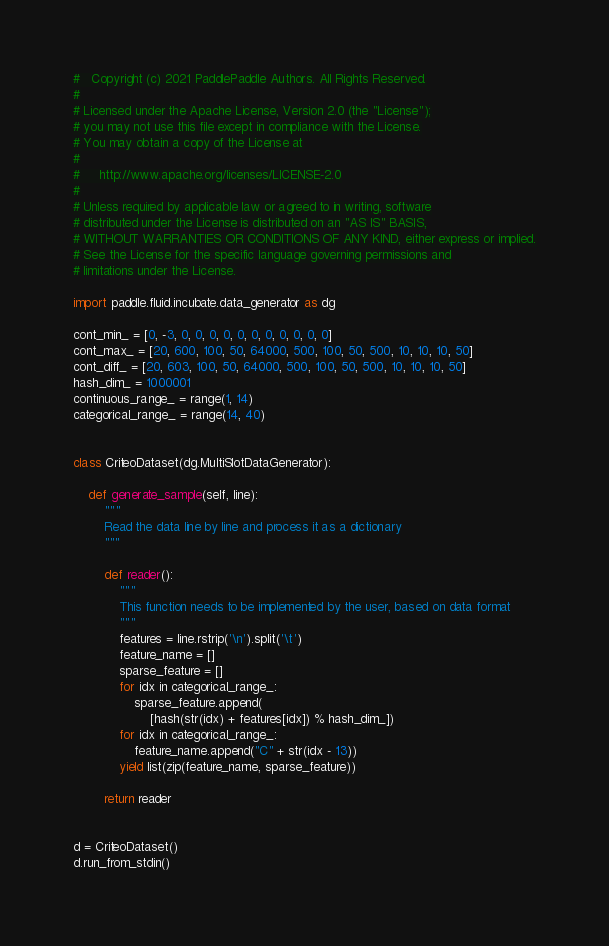Convert code to text. <code><loc_0><loc_0><loc_500><loc_500><_Python_>#   Copyright (c) 2021 PaddlePaddle Authors. All Rights Reserved.
#
# Licensed under the Apache License, Version 2.0 (the "License");
# you may not use this file except in compliance with the License.
# You may obtain a copy of the License at
#
#     http://www.apache.org/licenses/LICENSE-2.0
#
# Unless required by applicable law or agreed to in writing, software
# distributed under the License is distributed on an "AS IS" BASIS,
# WITHOUT WARRANTIES OR CONDITIONS OF ANY KIND, either express or implied.
# See the License for the specific language governing permissions and
# limitations under the License.

import paddle.fluid.incubate.data_generator as dg

cont_min_ = [0, -3, 0, 0, 0, 0, 0, 0, 0, 0, 0, 0, 0]
cont_max_ = [20, 600, 100, 50, 64000, 500, 100, 50, 500, 10, 10, 10, 50]
cont_diff_ = [20, 603, 100, 50, 64000, 500, 100, 50, 500, 10, 10, 10, 50]
hash_dim_ = 1000001
continuous_range_ = range(1, 14)
categorical_range_ = range(14, 40)


class CriteoDataset(dg.MultiSlotDataGenerator):

    def generate_sample(self, line):
        """
        Read the data line by line and process it as a dictionary
        """

        def reader():
            """
            This function needs to be implemented by the user, based on data format
            """
            features = line.rstrip('\n').split('\t')
            feature_name = []
            sparse_feature = []
            for idx in categorical_range_:
                sparse_feature.append(
                    [hash(str(idx) + features[idx]) % hash_dim_])
            for idx in categorical_range_:
                feature_name.append("C" + str(idx - 13))
            yield list(zip(feature_name, sparse_feature))

        return reader


d = CriteoDataset()
d.run_from_stdin()
</code> 